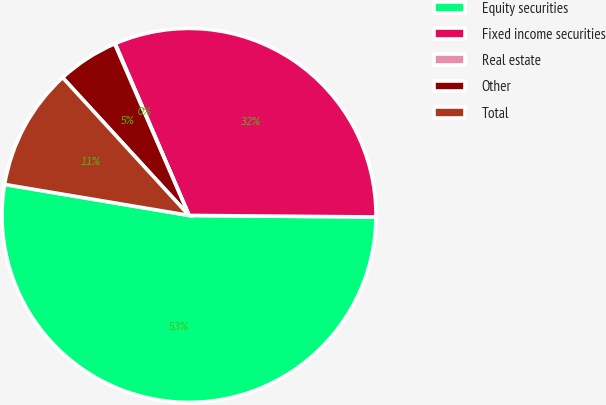Convert chart. <chart><loc_0><loc_0><loc_500><loc_500><pie_chart><fcel>Equity securities<fcel>Fixed income securities<fcel>Real estate<fcel>Other<fcel>Total<nl><fcel>52.51%<fcel>31.59%<fcel>0.05%<fcel>5.3%<fcel>10.54%<nl></chart> 